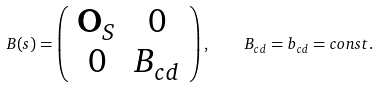Convert formula to latex. <formula><loc_0><loc_0><loc_500><loc_500>B ( s ) = \left ( \begin{array} { c c } \mathbf O _ { S } & 0 \\ 0 & B _ { c d } \end{array} \right ) , \quad B _ { c d } = b _ { c d } = c o n s t .</formula> 